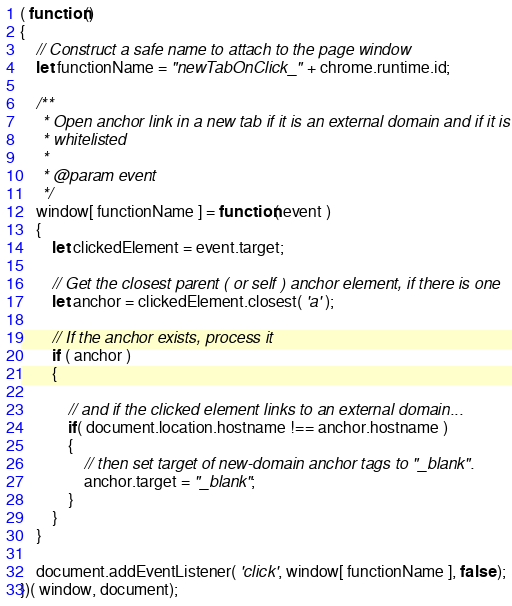Convert code to text. <code><loc_0><loc_0><loc_500><loc_500><_JavaScript_>( function()
{
    // Construct a safe name to attach to the page window
    let functionName = "newTabOnClick_" + chrome.runtime.id;

    /**
     * Open anchor link in a new tab if it is an external domain and if it is
     * whitelisted
     *
     * @param event
     */
    window[ functionName ] = function( event )
    {
        let clickedElement = event.target;

        // Get the closest parent ( or self ) anchor element, if there is one
        let anchor = clickedElement.closest( 'a' );

        // If the anchor exists, process it
        if ( anchor )
        {

            // and if the clicked element links to an external domain...
            if( document.location.hostname !== anchor.hostname )
            {
                // then set target of new-domain anchor tags to "_blank".
                anchor.target = "_blank";
            }
        }
    }

    document.addEventListener( 'click', window[ functionName ], false );
})( window, document);

</code> 